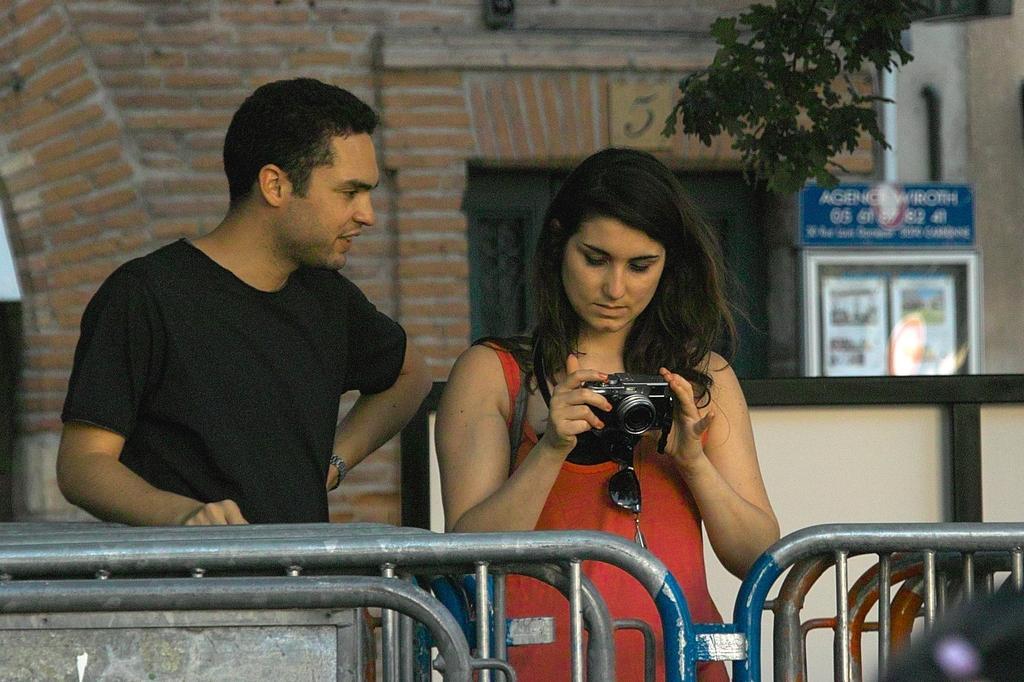Please provide a concise description of this image. In the picture I can see a person wearing black T-shirt is standing and there is a woman beside him is holding a camera in her hand and there is a fence in front of them and there is a building and some other objects in the background. 